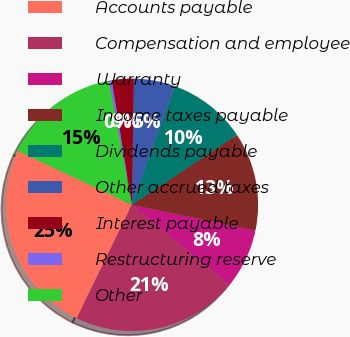Convert chart. <chart><loc_0><loc_0><loc_500><loc_500><pie_chart><fcel>Accounts payable<fcel>Compensation and employee<fcel>Warranty<fcel>Income taxes payable<fcel>Dividends payable<fcel>Other accrued taxes<fcel>Interest payable<fcel>Restructuring reserve<fcel>Other<nl><fcel>24.83%<fcel>21.23%<fcel>7.71%<fcel>12.6%<fcel>10.15%<fcel>5.26%<fcel>2.81%<fcel>0.36%<fcel>15.05%<nl></chart> 